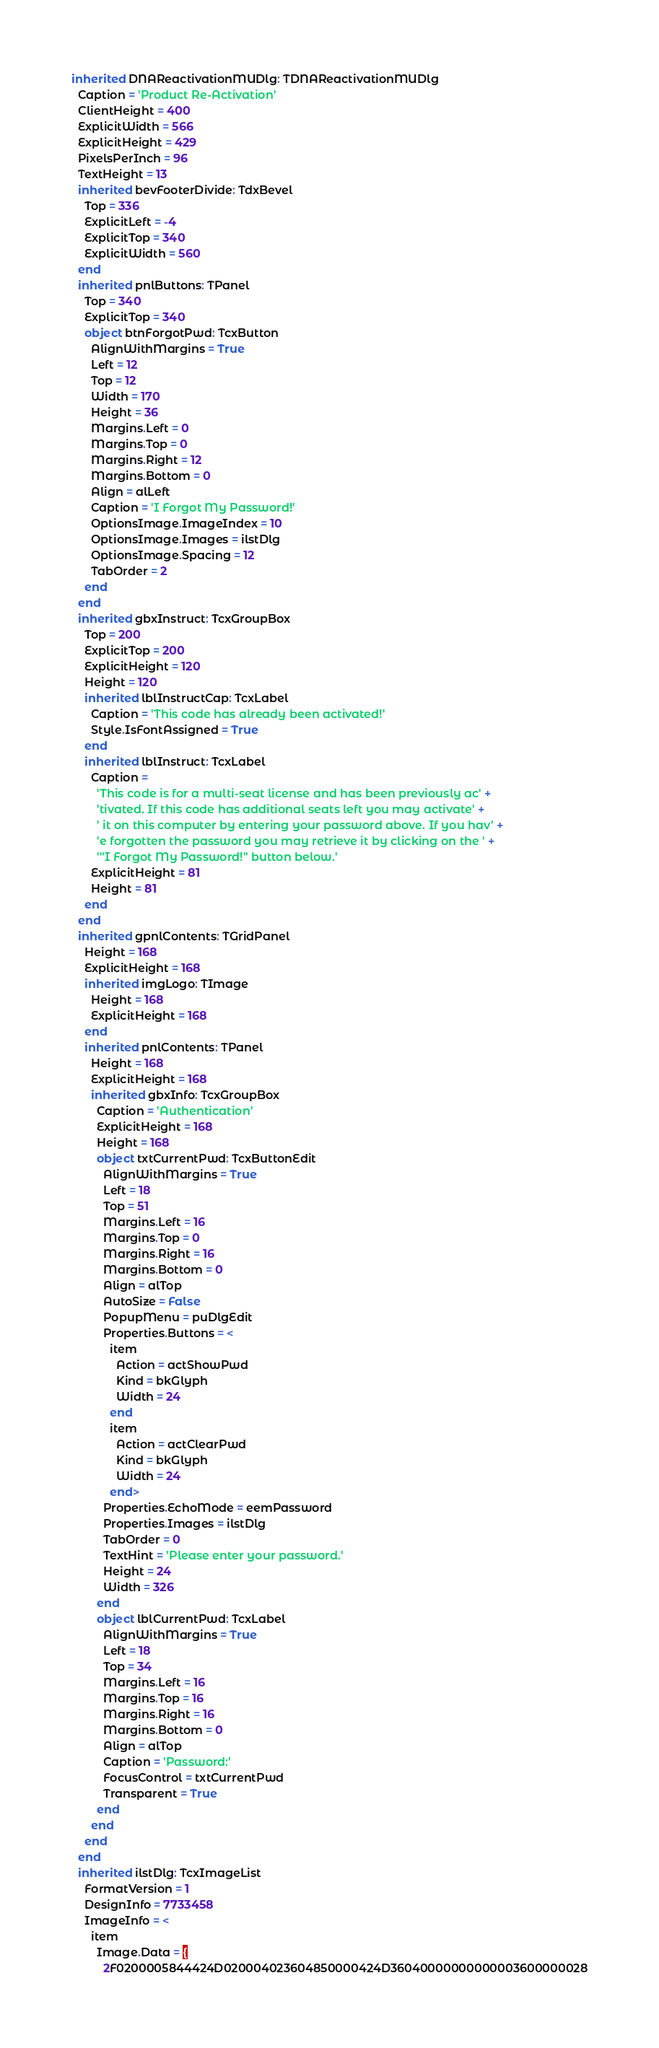<code> <loc_0><loc_0><loc_500><loc_500><_Pascal_>inherited DNAReactivationMUDlg: TDNAReactivationMUDlg
  Caption = 'Product Re-Activation'
  ClientHeight = 400
  ExplicitWidth = 566
  ExplicitHeight = 429
  PixelsPerInch = 96
  TextHeight = 13
  inherited bevFooterDivide: TdxBevel
    Top = 336
    ExplicitLeft = -4
    ExplicitTop = 340
    ExplicitWidth = 560
  end
  inherited pnlButtons: TPanel
    Top = 340
    ExplicitTop = 340
    object btnForgotPwd: TcxButton
      AlignWithMargins = True
      Left = 12
      Top = 12
      Width = 170
      Height = 36
      Margins.Left = 0
      Margins.Top = 0
      Margins.Right = 12
      Margins.Bottom = 0
      Align = alLeft
      Caption = 'I Forgot My Password!'
      OptionsImage.ImageIndex = 10
      OptionsImage.Images = ilstDlg
      OptionsImage.Spacing = 12
      TabOrder = 2
    end
  end
  inherited gbxInstruct: TcxGroupBox
    Top = 200
    ExplicitTop = 200
    ExplicitHeight = 120
    Height = 120
    inherited lblInstructCap: TcxLabel
      Caption = 'This code has already been activated!'
      Style.IsFontAssigned = True
    end
    inherited lblInstruct: TcxLabel
      Caption = 
        'This code is for a multi-seat license and has been previously ac' +
        'tivated. If this code has additional seats left you may activate' +
        ' it on this computer by entering your password above. If you hav' +
        'e forgotten the password you may retrieve it by clicking on the ' +
        '"I Forgot My Password!" button below.'
      ExplicitHeight = 81
      Height = 81
    end
  end
  inherited gpnlContents: TGridPanel
    Height = 168
    ExplicitHeight = 168
    inherited imgLogo: TImage
      Height = 168
      ExplicitHeight = 168
    end
    inherited pnlContents: TPanel
      Height = 168
      ExplicitHeight = 168
      inherited gbxInfo: TcxGroupBox
        Caption = 'Authentication'
        ExplicitHeight = 168
        Height = 168
        object txtCurrentPwd: TcxButtonEdit
          AlignWithMargins = True
          Left = 18
          Top = 51
          Margins.Left = 16
          Margins.Top = 0
          Margins.Right = 16
          Margins.Bottom = 0
          Align = alTop
          AutoSize = False
          PopupMenu = puDlgEdit
          Properties.Buttons = <
            item
              Action = actShowPwd
              Kind = bkGlyph
              Width = 24
            end
            item
              Action = actClearPwd
              Kind = bkGlyph
              Width = 24
            end>
          Properties.EchoMode = eemPassword
          Properties.Images = ilstDlg
          TabOrder = 0
          TextHint = 'Please enter your password.'
          Height = 24
          Width = 326
        end
        object lblCurrentPwd: TcxLabel
          AlignWithMargins = True
          Left = 18
          Top = 34
          Margins.Left = 16
          Margins.Top = 16
          Margins.Right = 16
          Margins.Bottom = 0
          Align = alTop
          Caption = 'Password:'
          FocusControl = txtCurrentPwd
          Transparent = True
        end
      end
    end
  end
  inherited ilstDlg: TcxImageList
    FormatVersion = 1
    DesignInfo = 7733458
    ImageInfo = <
      item
        Image.Data = {
          2F0200005844424D020004023604850000424D36040000000000003600000028</code> 